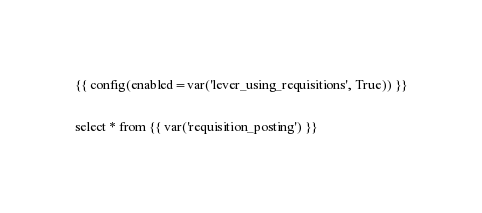Convert code to text. <code><loc_0><loc_0><loc_500><loc_500><_SQL_>{{ config(enabled=var('lever_using_requisitions', True)) }}

select * from {{ var('requisition_posting') }}
</code> 